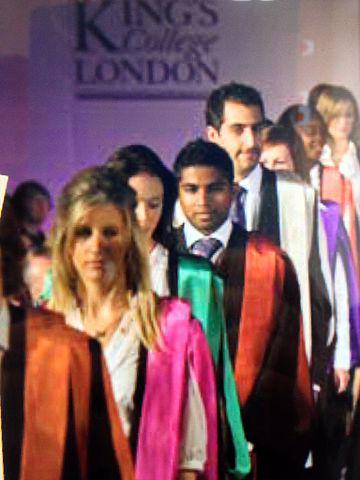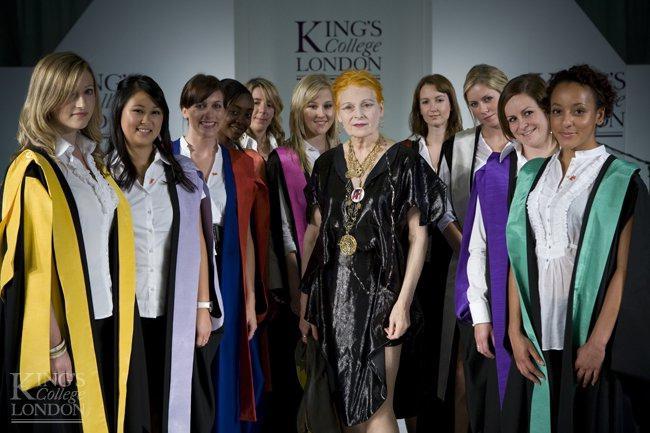The first image is the image on the left, the second image is the image on the right. Analyze the images presented: Is the assertion "At least three people are wearing yellow graduation stoles in the image on the left." valid? Answer yes or no. No. The first image is the image on the left, the second image is the image on the right. Evaluate the accuracy of this statement regarding the images: "Multiple young women in black and yellow stand in the foreground of an image.". Is it true? Answer yes or no. No. 